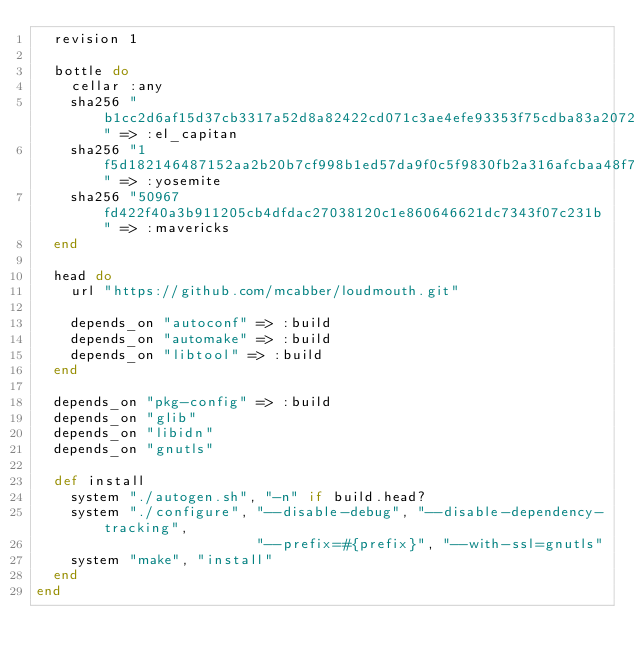Convert code to text. <code><loc_0><loc_0><loc_500><loc_500><_Ruby_>  revision 1

  bottle do
    cellar :any
    sha256 "b1cc2d6af15d37cb3317a52d8a82422cd071c3ae4efe93353f75cdba83a20723" => :el_capitan
    sha256 "1f5d182146487152aa2b20b7cf998b1ed57da9f0c5f9830fb2a316afcbaa48f7" => :yosemite
    sha256 "50967fd422f40a3b911205cb4dfdac27038120c1e860646621dc7343f07c231b" => :mavericks
  end

  head do
    url "https://github.com/mcabber/loudmouth.git"

    depends_on "autoconf" => :build
    depends_on "automake" => :build
    depends_on "libtool" => :build
  end

  depends_on "pkg-config" => :build
  depends_on "glib"
  depends_on "libidn"
  depends_on "gnutls"

  def install
    system "./autogen.sh", "-n" if build.head?
    system "./configure", "--disable-debug", "--disable-dependency-tracking",
                          "--prefix=#{prefix}", "--with-ssl=gnutls"
    system "make", "install"
  end
end
</code> 